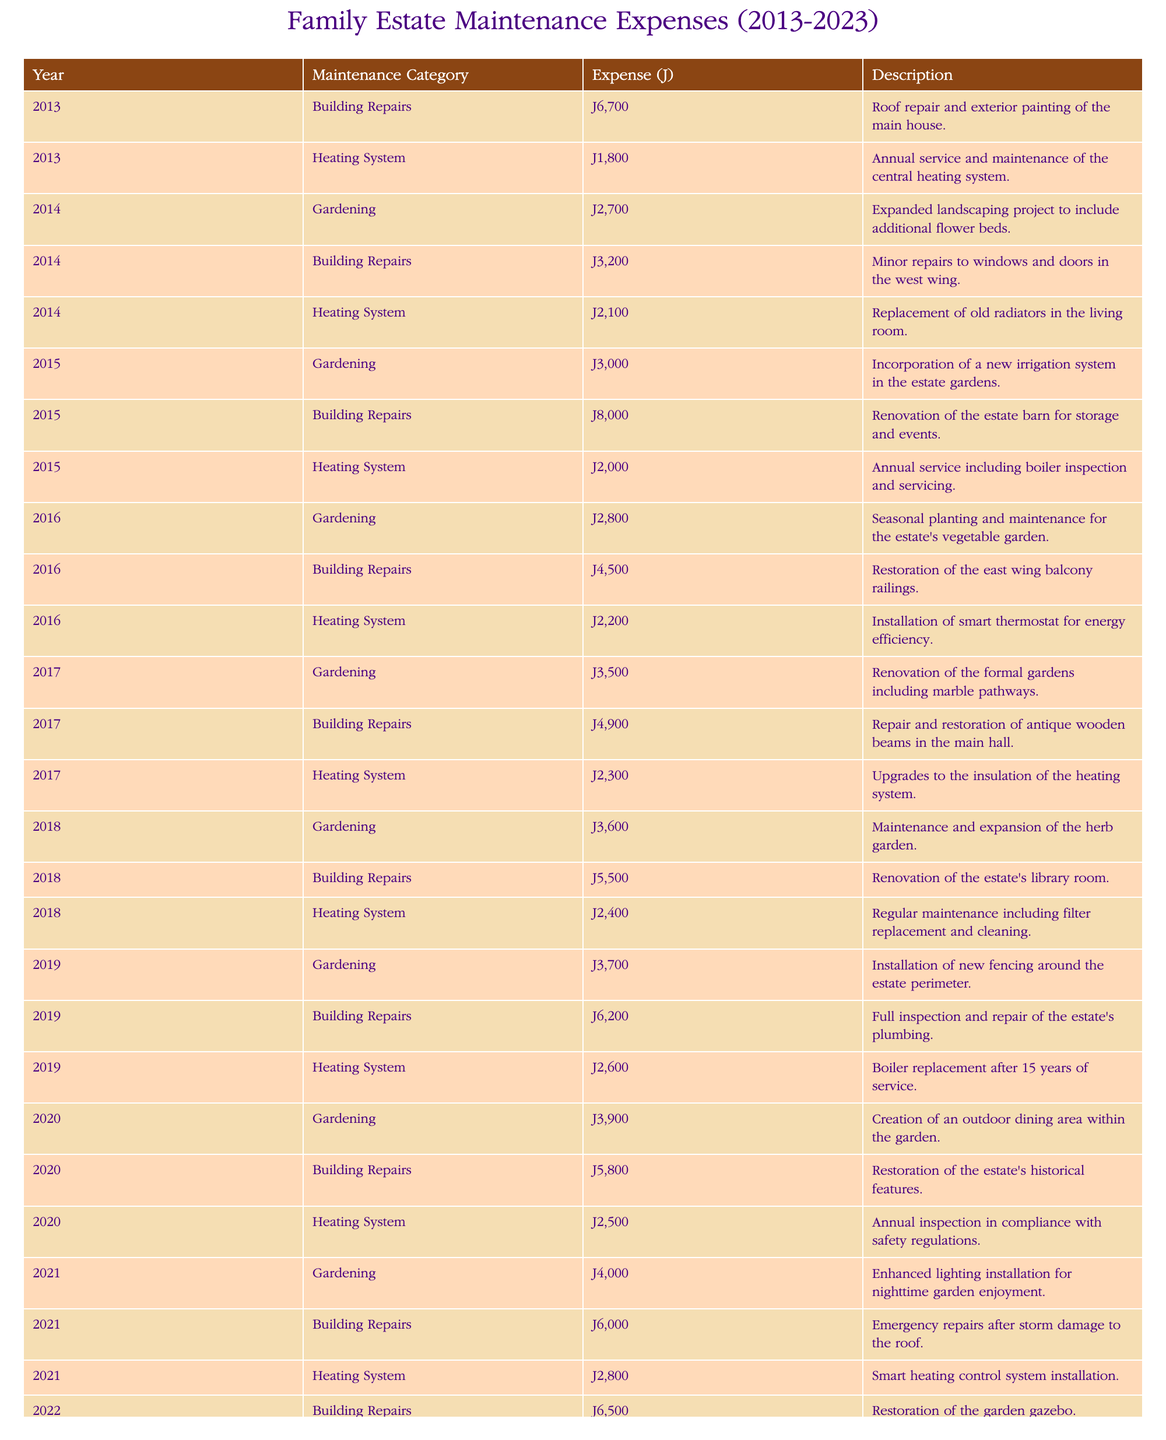What was the total expense on gardening in 2019? Referring to the table, the expense for gardening in 2019 is £3,700. This value is directly listed in the row for the gardening expenses for that year.
Answer: £3,700 What was the highest expense on building repairs in a single year? By examining the building repairs expenses by year, the highest expense recorded is £8,000 in 2015. This figure is the maximum when compared to all other building repair entries.
Answer: £8,000 Did any year see more than £10,000 spent on heating system repairs? Looking through the table, there is no entry where the heating system expenses exceed £10,000 in any year; the maximum recorded is £3,000 in 2023.
Answer: No What was the average annual expense on gardening over the decade? The total gardening expenses from 2013 to 2023 are £27,400, calculated by summing up each year's gardening expenses: £2,700 + £3,000 + £2,800 + £3,500 + £3,600 + £3,700 + £3,900 + £4,000 + £4,500 = £27,400. With 9 data points, the average is £27,400 divided by 9, resulting in approximately £3,044.44.
Answer: £3,044.44 In which year was the least total amount spent on heating system maintenance? Analyzing the heating system expenses year by year reveals that the least total spent was £1,800 in 2013, which is the only entry in that year.
Answer: 2013 What is the total expense on building repairs across all years? Summing up all the building repairs expenses yields £58,200, calculated as follows: £6,700 (2013) + £3,200 (2014) + £8,000 (2015) + £4,500 (2016) + £4,900 (2017) + £5,500 (2018) + £6,200 (2019) + £5,800 (2020) + £6,000 (2021) + £6,500 (2022) + £7,000 (2023) = £58,200.
Answer: £58,200 Was there any expense category in 2020 that exceeded £5,000? The expenses in 2020 for gardening (£3,900), building repairs (£5,800), and heating systems (£2,500) can all be compared. The building repairs are £5,800, which is the only one exceeding £5,000.
Answer: Yes Which maintenance category had uniform increases over each consecutive year? Examining the values shows that the gardening expenses increased each year from 2013 to 2023: £2,700 (2013), £3,000 (2014), £2,800 (2016), £3,500 (2017), £3,600 (2018), £3,700 (2019), £3,900 (2020), £4,000 (2021), £4,500 (2023). Hence, gardening shows a trend of consistent increases.
Answer: Gardening 